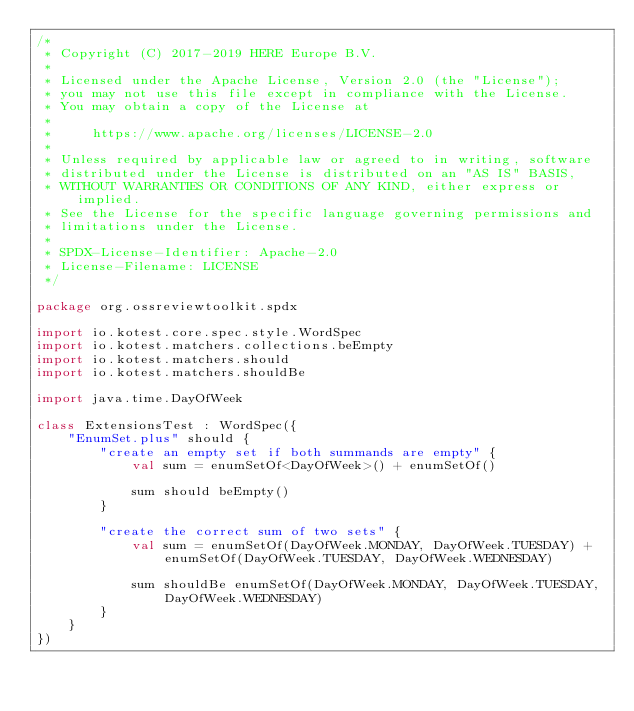Convert code to text. <code><loc_0><loc_0><loc_500><loc_500><_Kotlin_>/*
 * Copyright (C) 2017-2019 HERE Europe B.V.
 *
 * Licensed under the Apache License, Version 2.0 (the "License");
 * you may not use this file except in compliance with the License.
 * You may obtain a copy of the License at
 *
 *     https://www.apache.org/licenses/LICENSE-2.0
 *
 * Unless required by applicable law or agreed to in writing, software
 * distributed under the License is distributed on an "AS IS" BASIS,
 * WITHOUT WARRANTIES OR CONDITIONS OF ANY KIND, either express or implied.
 * See the License for the specific language governing permissions and
 * limitations under the License.
 *
 * SPDX-License-Identifier: Apache-2.0
 * License-Filename: LICENSE
 */

package org.ossreviewtoolkit.spdx

import io.kotest.core.spec.style.WordSpec
import io.kotest.matchers.collections.beEmpty
import io.kotest.matchers.should
import io.kotest.matchers.shouldBe

import java.time.DayOfWeek

class ExtensionsTest : WordSpec({
    "EnumSet.plus" should {
        "create an empty set if both summands are empty" {
            val sum = enumSetOf<DayOfWeek>() + enumSetOf()

            sum should beEmpty()
        }

        "create the correct sum of two sets" {
            val sum = enumSetOf(DayOfWeek.MONDAY, DayOfWeek.TUESDAY) + enumSetOf(DayOfWeek.TUESDAY, DayOfWeek.WEDNESDAY)

            sum shouldBe enumSetOf(DayOfWeek.MONDAY, DayOfWeek.TUESDAY, DayOfWeek.WEDNESDAY)
        }
    }
})
</code> 